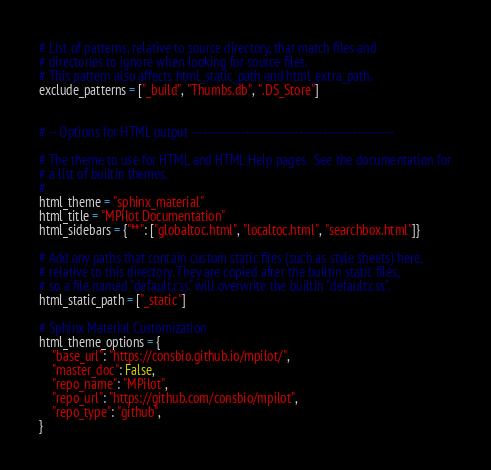Convert code to text. <code><loc_0><loc_0><loc_500><loc_500><_Python_>
# List of patterns, relative to source directory, that match files and
# directories to ignore when looking for source files.
# This pattern also affects html_static_path and html_extra_path.
exclude_patterns = ["_build", "Thumbs.db", ".DS_Store"]


# -- Options for HTML output -------------------------------------------------

# The theme to use for HTML and HTML Help pages.  See the documentation for
# a list of builtin themes.
#
html_theme = "sphinx_material"
html_title = "MPilot Documentation"
html_sidebars = {"**": ["globaltoc.html", "localtoc.html", "searchbox.html"]}

# Add any paths that contain custom static files (such as style sheets) here,
# relative to this directory. They are copied after the builtin static files,
# so a file named "default.css" will overwrite the builtin "default.css".
html_static_path = ["_static"]

# Sphinx Material Customization
html_theme_options = {
    "base_url": "https://consbio.github.io/mpilot/",
    "master_doc": False,
    "repo_name": "MPilot",
    "repo_url": "https://github.com/consbio/mpilot",
    "repo_type": "github",
}
</code> 